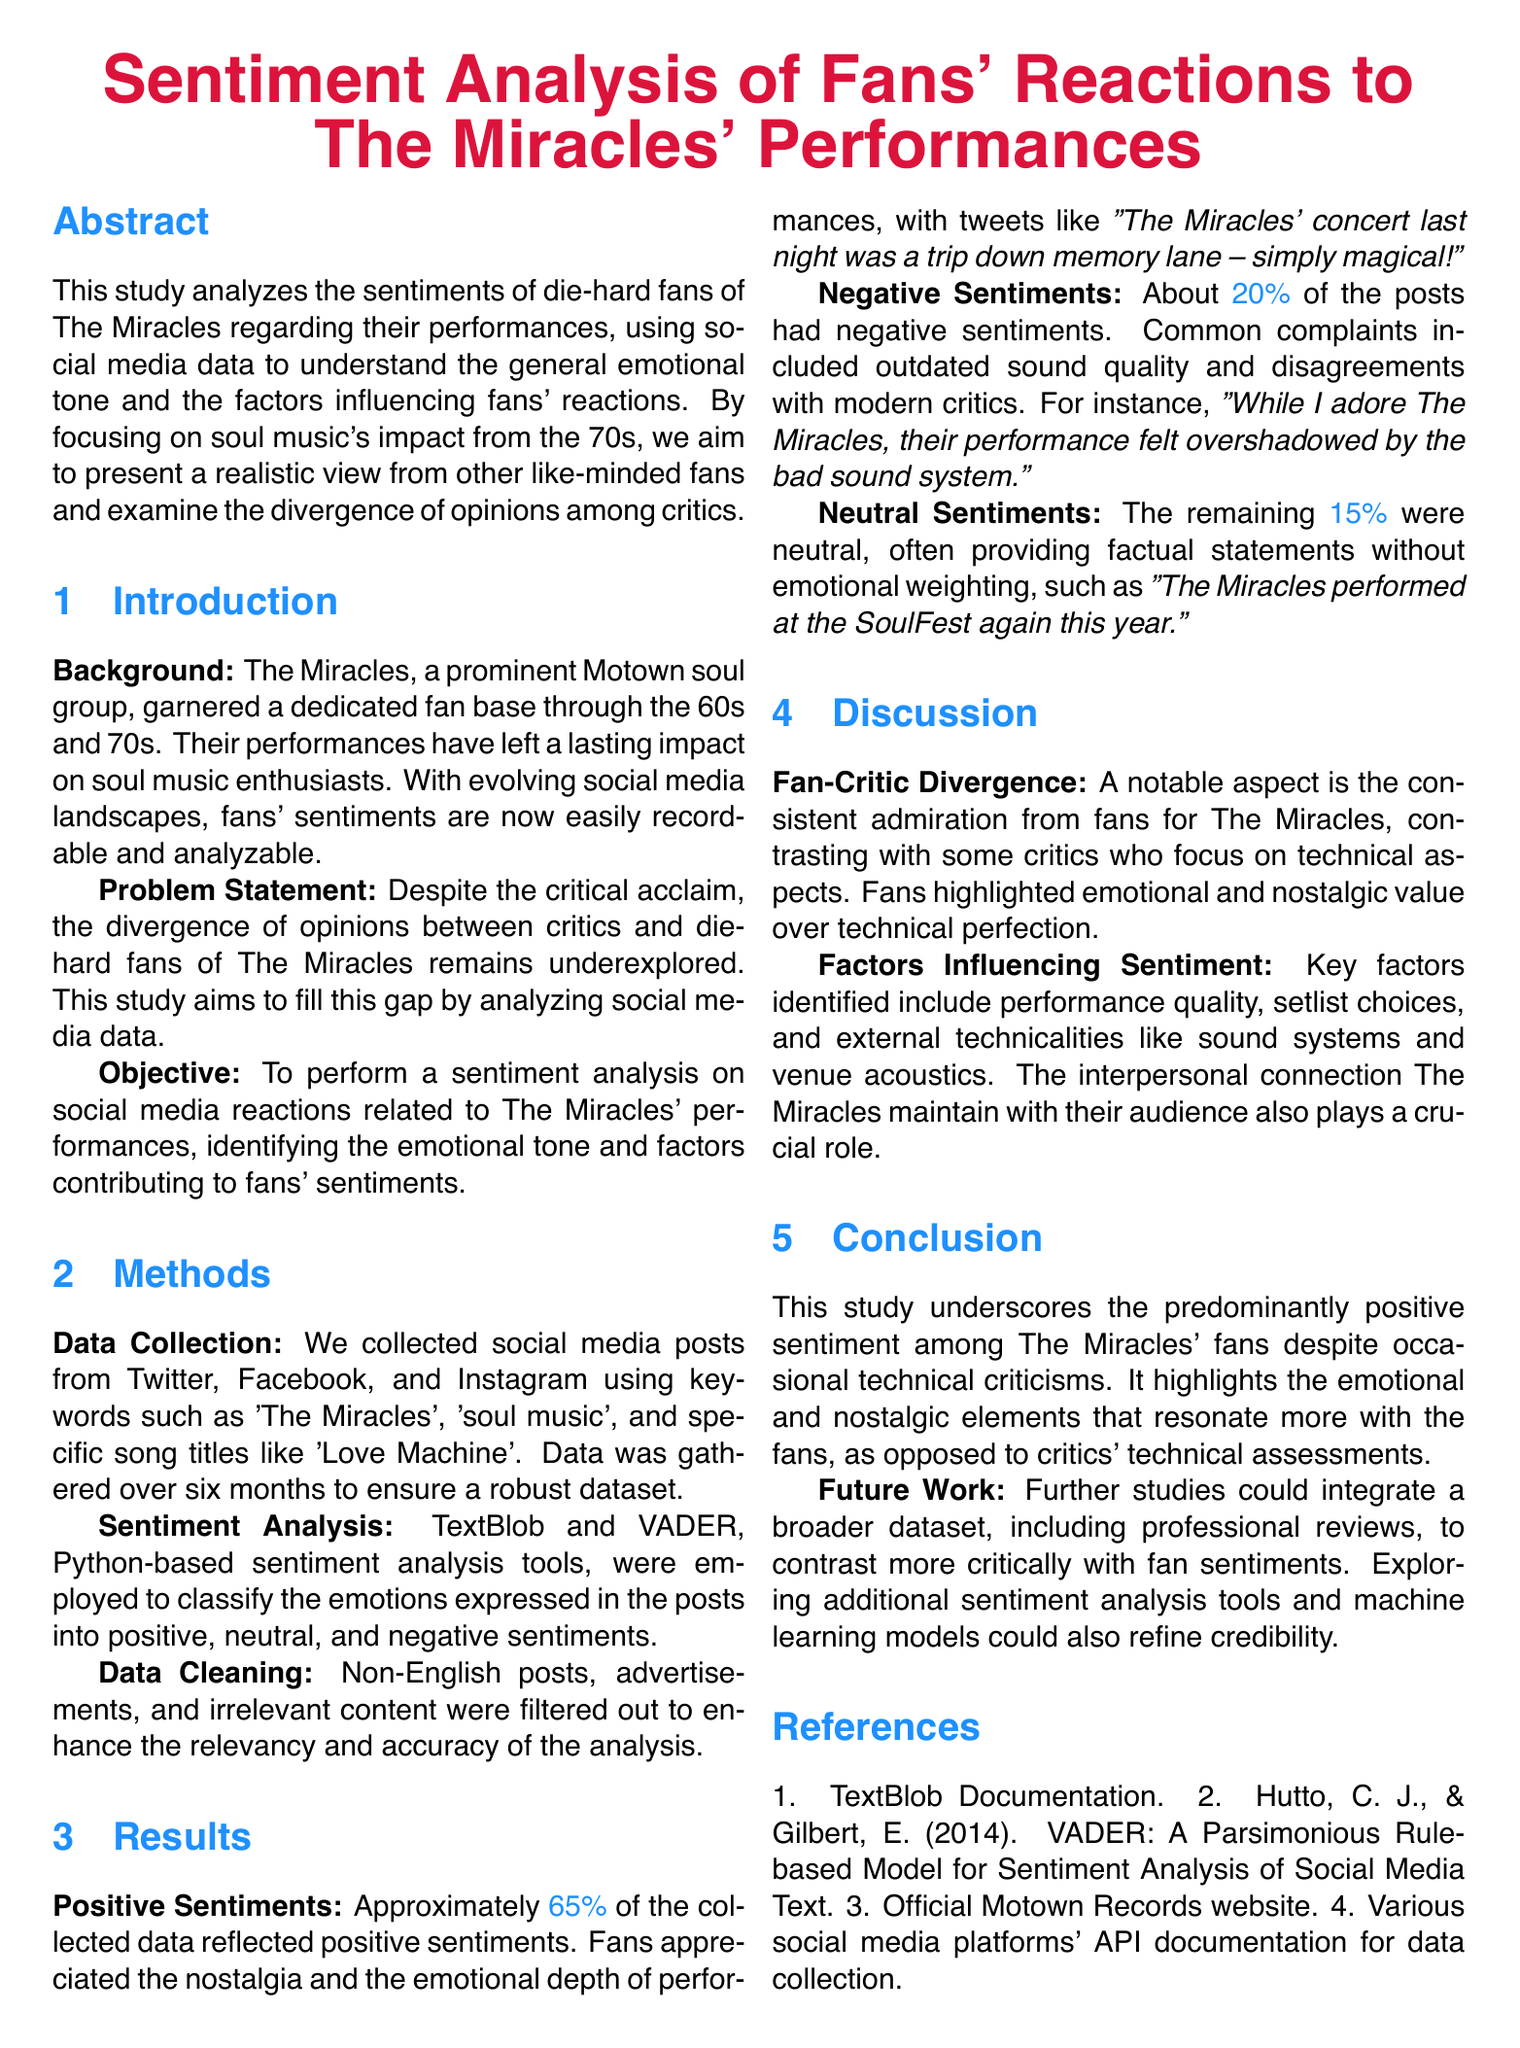What is the title of the study? The title of the study is presented prominently at the beginning of the document.
Answer: Sentiment Analysis of Fans' Reactions to The Miracles' Performances What percentage of positive sentiments was found in the study? The document specifies the percentage of positive sentiments derived from the sentiment analysis results.
Answer: 65% What key factor influences fan sentiment according to the study? The study highlights an important aspect that influences how fans feel about The Miracles' performances.
Answer: Performance quality What is the main objective of the study? The objective is outlined in the introduction section, defining the focus of the research.
Answer: To perform a sentiment analysis on social media reactions What sentiment analysis tools were used in the study? The methods section lists the specific tools employed for analyzing sentiments in the collected data.
Answer: TextBlob and VADER What percentage of the posts displayed negative sentiments? The results section provides specific statistics on the sentiments expressed in social media posts regarding The Miracles.
Answer: 20% What is one of the future work suggestions mentioned in the conclusion? The conclusion suggests a direction for further research based on findings from the current study.
Answer: Integrate a broader dataset What type of posts were filtered out during data cleaning? The document explains which types of content were excluded to improve data quality for the analysis.
Answer: Non-English posts What contrasting views are discussed in the document? The discussion addresses differing perspectives between two groups regarding The Miracles' performances.
Answer: Fan-Critic Divergence 